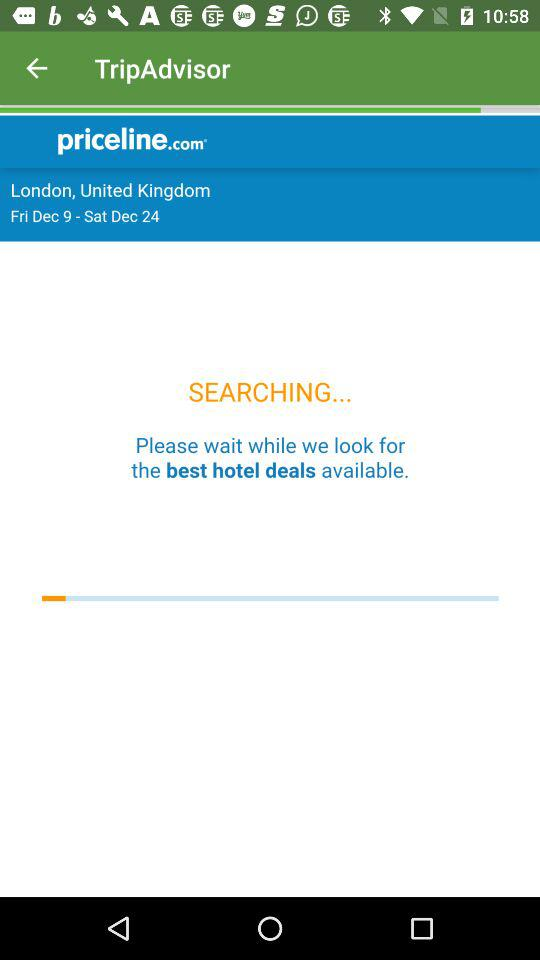What is the name of the application? The name of the application is "TripAdvisor". 